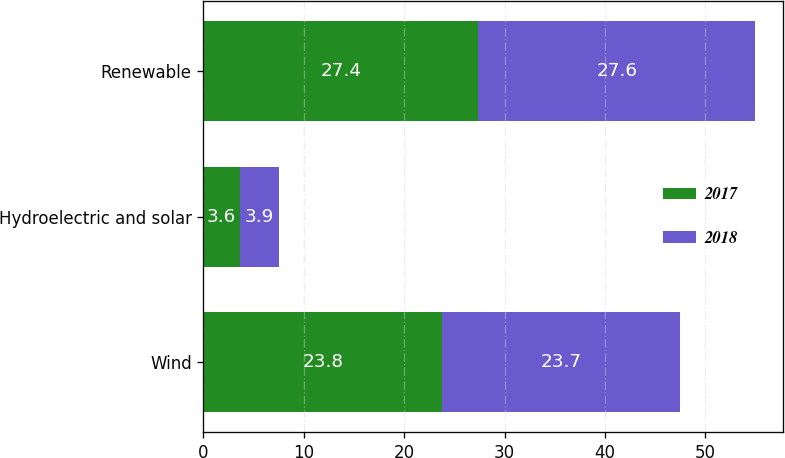Convert chart. <chart><loc_0><loc_0><loc_500><loc_500><stacked_bar_chart><ecel><fcel>Wind<fcel>Hydroelectric and solar<fcel>Renewable<nl><fcel>2017<fcel>23.8<fcel>3.6<fcel>27.4<nl><fcel>2018<fcel>23.7<fcel>3.9<fcel>27.6<nl></chart> 